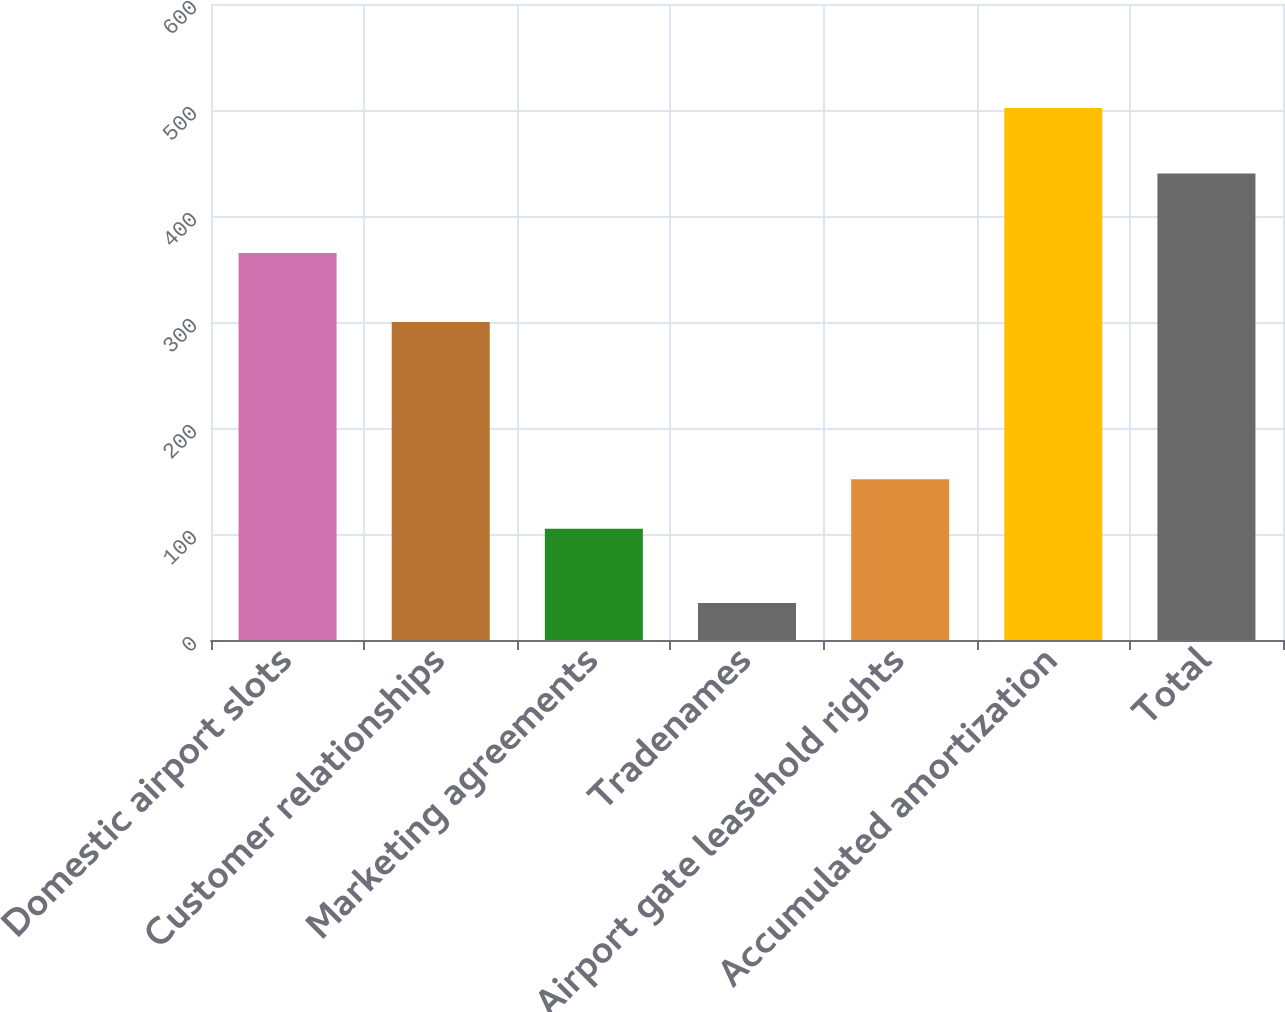Convert chart. <chart><loc_0><loc_0><loc_500><loc_500><bar_chart><fcel>Domestic airport slots<fcel>Customer relationships<fcel>Marketing agreements<fcel>Tradenames<fcel>Airport gate leasehold rights<fcel>Accumulated amortization<fcel>Total<nl><fcel>365<fcel>300<fcel>105<fcel>35<fcel>151.7<fcel>502<fcel>440<nl></chart> 